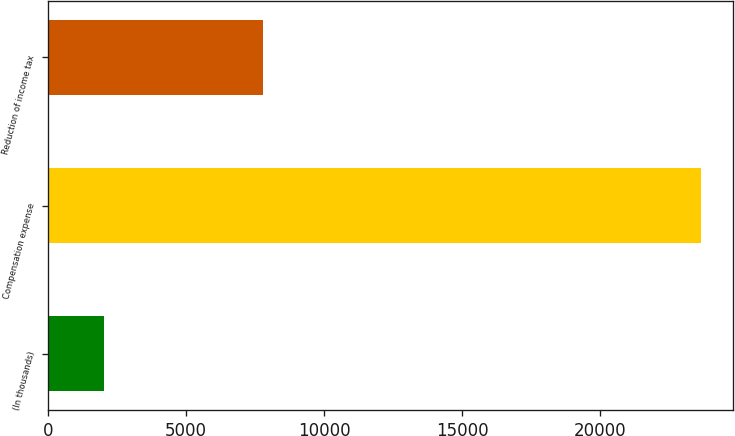Convert chart. <chart><loc_0><loc_0><loc_500><loc_500><bar_chart><fcel>(In thousands)<fcel>Compensation expense<fcel>Reduction of income tax<nl><fcel>2014<fcel>23632<fcel>7767<nl></chart> 